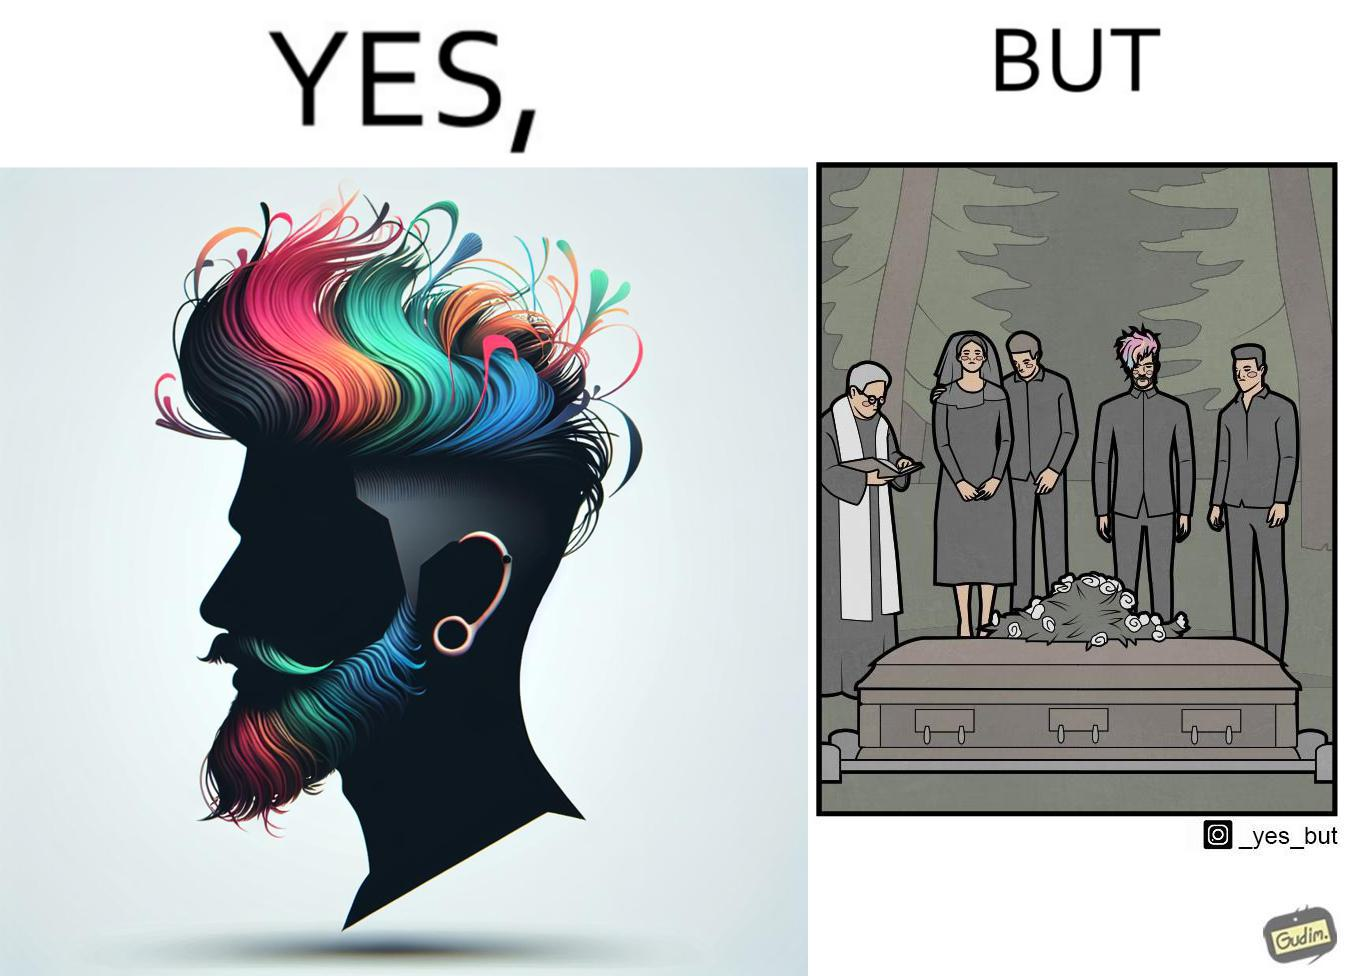Explain the humor or irony in this image. The image is ironic, because in the second image it is shown that a group of people is attending someone's death ceremony but one of them is shown as wrongly dressed for that place in first image, his visual appearances doesn't shows his feeling of mourning 